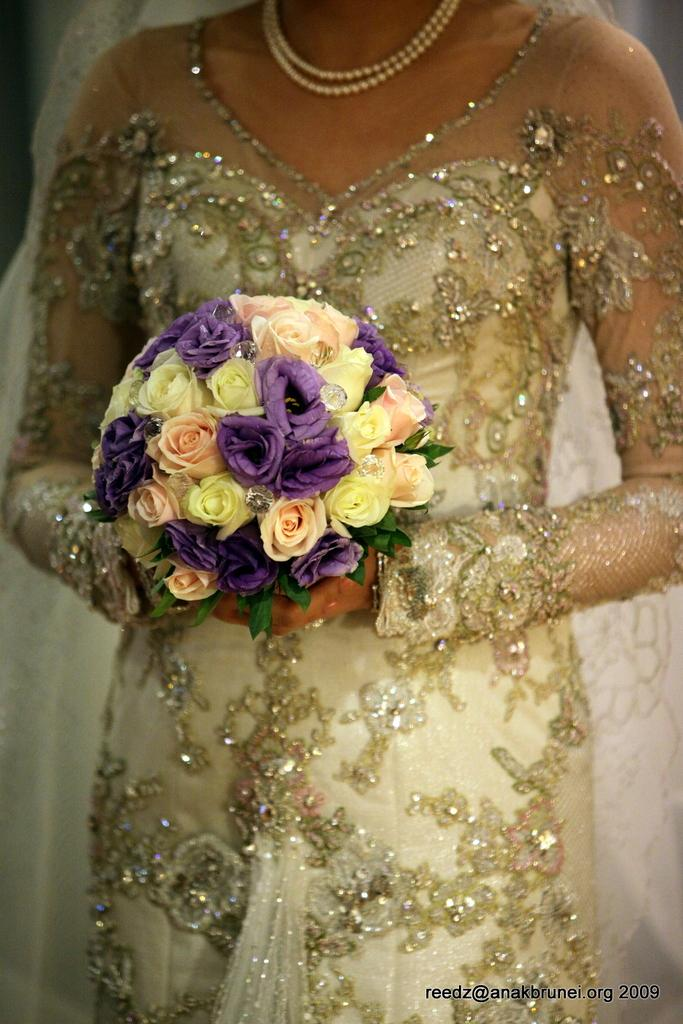Who is the main subject in the image? There is a lady in the image. What is the lady holding in the image? The lady is holding a bouquet. Is there any text present in the image? Yes, there is text at the bottom of the image. What flavor of ice cream is the lady holding in the image? There is no ice cream present in the image; the lady is holding a bouquet. How many letters does the lady know how to write in the image? There is no indication in the image that the lady is writing or that her knowledge of letters is relevant to the image. 